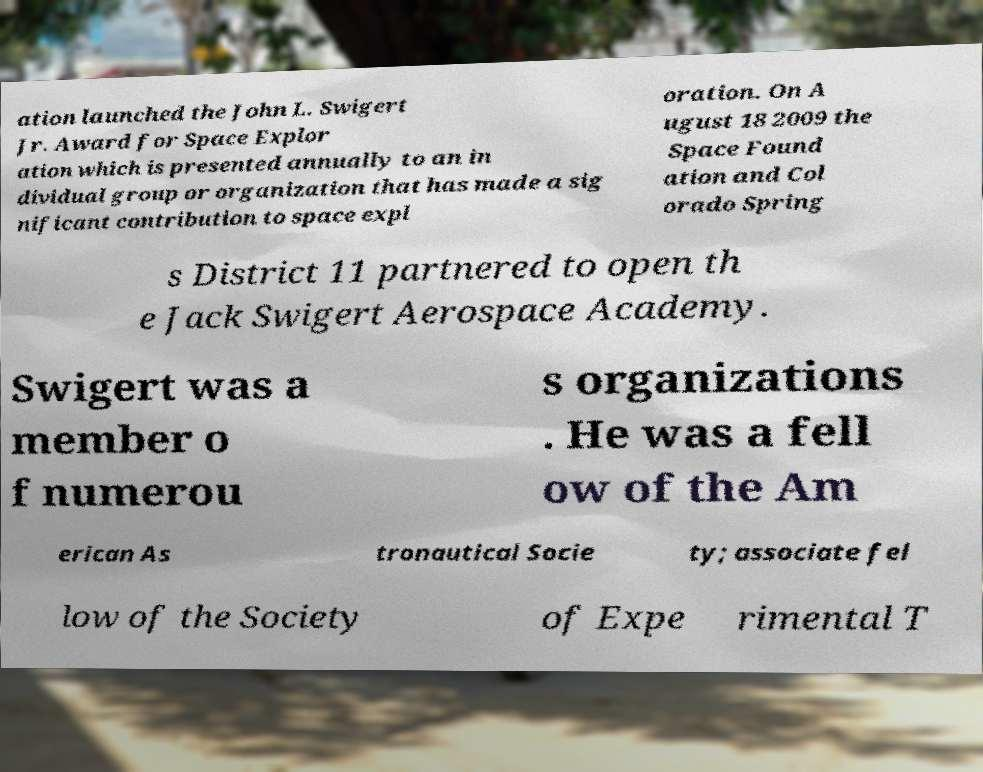Can you read and provide the text displayed in the image?This photo seems to have some interesting text. Can you extract and type it out for me? ation launched the John L. Swigert Jr. Award for Space Explor ation which is presented annually to an in dividual group or organization that has made a sig nificant contribution to space expl oration. On A ugust 18 2009 the Space Found ation and Col orado Spring s District 11 partnered to open th e Jack Swigert Aerospace Academy. Swigert was a member o f numerou s organizations . He was a fell ow of the Am erican As tronautical Socie ty; associate fel low of the Society of Expe rimental T 